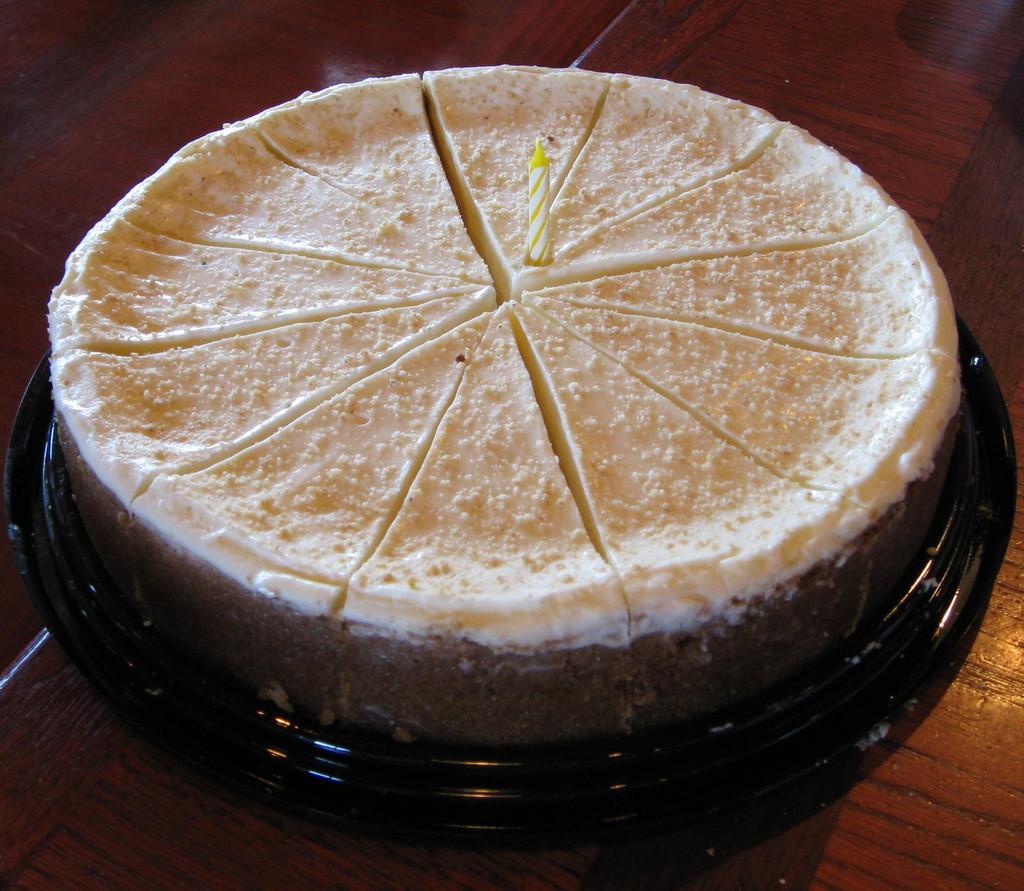Could you give a brief overview of what you see in this image? In this image we can see there is a table, on the table there is a cake on the plate and there is a candle. 